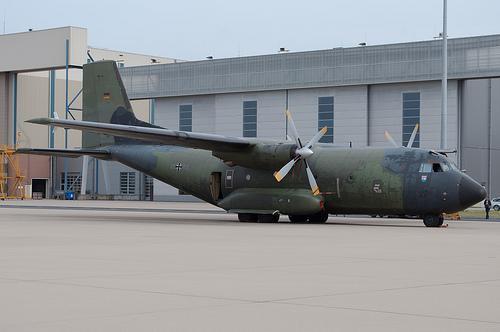How many planes are pictured?
Give a very brief answer. 1. 